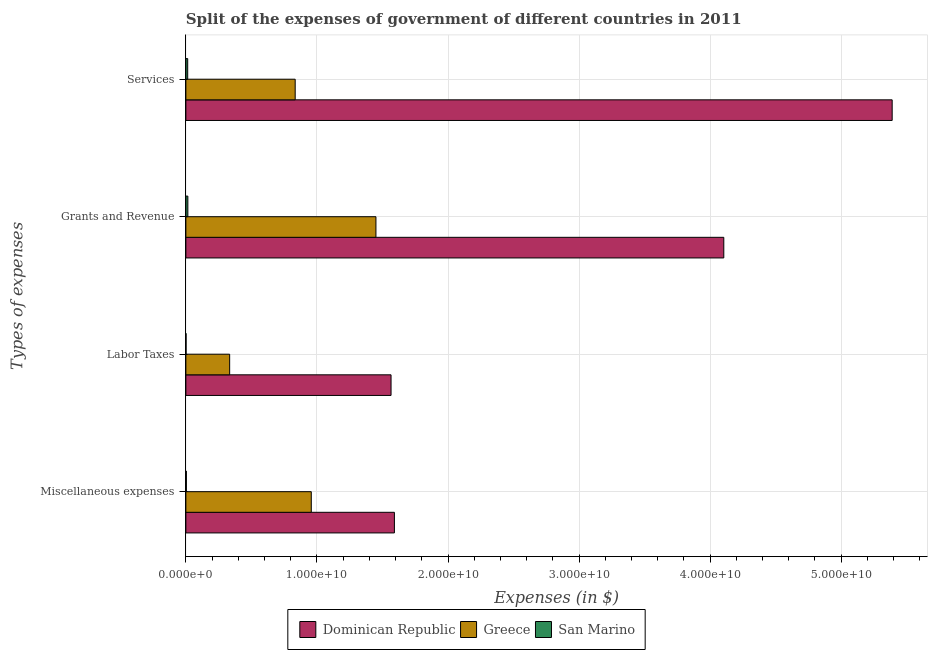How many groups of bars are there?
Your response must be concise. 4. How many bars are there on the 4th tick from the top?
Make the answer very short. 3. How many bars are there on the 3rd tick from the bottom?
Your answer should be very brief. 3. What is the label of the 3rd group of bars from the top?
Provide a succinct answer. Labor Taxes. What is the amount spent on miscellaneous expenses in Greece?
Offer a terse response. 9.57e+09. Across all countries, what is the maximum amount spent on services?
Your answer should be very brief. 5.39e+1. Across all countries, what is the minimum amount spent on miscellaneous expenses?
Provide a short and direct response. 3.76e+07. In which country was the amount spent on services maximum?
Keep it short and to the point. Dominican Republic. In which country was the amount spent on miscellaneous expenses minimum?
Ensure brevity in your answer.  San Marino. What is the total amount spent on miscellaneous expenses in the graph?
Provide a succinct answer. 2.55e+1. What is the difference between the amount spent on miscellaneous expenses in San Marino and that in Dominican Republic?
Make the answer very short. -1.59e+1. What is the difference between the amount spent on services in Dominican Republic and the amount spent on grants and revenue in Greece?
Make the answer very short. 3.94e+1. What is the average amount spent on miscellaneous expenses per country?
Offer a terse response. 8.51e+09. What is the difference between the amount spent on miscellaneous expenses and amount spent on services in Dominican Republic?
Keep it short and to the point. -3.80e+1. What is the ratio of the amount spent on labor taxes in San Marino to that in Greece?
Give a very brief answer. 0. Is the amount spent on services in Greece less than that in Dominican Republic?
Make the answer very short. Yes. Is the difference between the amount spent on services in Dominican Republic and Greece greater than the difference between the amount spent on labor taxes in Dominican Republic and Greece?
Make the answer very short. Yes. What is the difference between the highest and the second highest amount spent on grants and revenue?
Ensure brevity in your answer.  2.65e+1. What is the difference between the highest and the lowest amount spent on miscellaneous expenses?
Give a very brief answer. 1.59e+1. Is the sum of the amount spent on services in Dominican Republic and San Marino greater than the maximum amount spent on miscellaneous expenses across all countries?
Offer a very short reply. Yes. What does the 3rd bar from the top in Miscellaneous expenses represents?
Give a very brief answer. Dominican Republic. What does the 1st bar from the bottom in Services represents?
Make the answer very short. Dominican Republic. How many bars are there?
Your answer should be compact. 12. How many countries are there in the graph?
Give a very brief answer. 3. What is the difference between two consecutive major ticks on the X-axis?
Offer a terse response. 1.00e+1. Are the values on the major ticks of X-axis written in scientific E-notation?
Make the answer very short. Yes. Does the graph contain grids?
Provide a short and direct response. Yes. Where does the legend appear in the graph?
Ensure brevity in your answer.  Bottom center. How are the legend labels stacked?
Your answer should be compact. Horizontal. What is the title of the graph?
Offer a terse response. Split of the expenses of government of different countries in 2011. What is the label or title of the X-axis?
Ensure brevity in your answer.  Expenses (in $). What is the label or title of the Y-axis?
Your response must be concise. Types of expenses. What is the Expenses (in $) in Dominican Republic in Miscellaneous expenses?
Give a very brief answer. 1.59e+1. What is the Expenses (in $) of Greece in Miscellaneous expenses?
Your answer should be compact. 9.57e+09. What is the Expenses (in $) of San Marino in Miscellaneous expenses?
Your answer should be compact. 3.76e+07. What is the Expenses (in $) in Dominican Republic in Labor Taxes?
Offer a very short reply. 1.57e+1. What is the Expenses (in $) in Greece in Labor Taxes?
Your answer should be very brief. 3.34e+09. What is the Expenses (in $) of San Marino in Labor Taxes?
Your answer should be very brief. 1.45e+07. What is the Expenses (in $) in Dominican Republic in Grants and Revenue?
Your answer should be very brief. 4.10e+1. What is the Expenses (in $) of Greece in Grants and Revenue?
Offer a very short reply. 1.45e+1. What is the Expenses (in $) of San Marino in Grants and Revenue?
Offer a terse response. 1.51e+08. What is the Expenses (in $) in Dominican Republic in Services?
Offer a terse response. 5.39e+1. What is the Expenses (in $) in Greece in Services?
Provide a short and direct response. 8.34e+09. What is the Expenses (in $) in San Marino in Services?
Your response must be concise. 1.39e+08. Across all Types of expenses, what is the maximum Expenses (in $) in Dominican Republic?
Offer a terse response. 5.39e+1. Across all Types of expenses, what is the maximum Expenses (in $) in Greece?
Offer a very short reply. 1.45e+1. Across all Types of expenses, what is the maximum Expenses (in $) of San Marino?
Provide a succinct answer. 1.51e+08. Across all Types of expenses, what is the minimum Expenses (in $) of Dominican Republic?
Ensure brevity in your answer.  1.57e+1. Across all Types of expenses, what is the minimum Expenses (in $) in Greece?
Give a very brief answer. 3.34e+09. Across all Types of expenses, what is the minimum Expenses (in $) of San Marino?
Make the answer very short. 1.45e+07. What is the total Expenses (in $) in Dominican Republic in the graph?
Your answer should be very brief. 1.27e+11. What is the total Expenses (in $) in Greece in the graph?
Offer a terse response. 3.58e+1. What is the total Expenses (in $) of San Marino in the graph?
Your answer should be compact. 3.43e+08. What is the difference between the Expenses (in $) of Dominican Republic in Miscellaneous expenses and that in Labor Taxes?
Provide a succinct answer. 2.57e+08. What is the difference between the Expenses (in $) of Greece in Miscellaneous expenses and that in Labor Taxes?
Keep it short and to the point. 6.23e+09. What is the difference between the Expenses (in $) in San Marino in Miscellaneous expenses and that in Labor Taxes?
Your answer should be compact. 2.31e+07. What is the difference between the Expenses (in $) of Dominican Republic in Miscellaneous expenses and that in Grants and Revenue?
Your answer should be very brief. -2.51e+1. What is the difference between the Expenses (in $) of Greece in Miscellaneous expenses and that in Grants and Revenue?
Your answer should be very brief. -4.93e+09. What is the difference between the Expenses (in $) of San Marino in Miscellaneous expenses and that in Grants and Revenue?
Make the answer very short. -1.14e+08. What is the difference between the Expenses (in $) in Dominican Republic in Miscellaneous expenses and that in Services?
Your response must be concise. -3.80e+1. What is the difference between the Expenses (in $) of Greece in Miscellaneous expenses and that in Services?
Offer a terse response. 1.23e+09. What is the difference between the Expenses (in $) of San Marino in Miscellaneous expenses and that in Services?
Offer a terse response. -1.02e+08. What is the difference between the Expenses (in $) in Dominican Republic in Labor Taxes and that in Grants and Revenue?
Keep it short and to the point. -2.54e+1. What is the difference between the Expenses (in $) in Greece in Labor Taxes and that in Grants and Revenue?
Your answer should be very brief. -1.12e+1. What is the difference between the Expenses (in $) in San Marino in Labor Taxes and that in Grants and Revenue?
Your answer should be very brief. -1.37e+08. What is the difference between the Expenses (in $) of Dominican Republic in Labor Taxes and that in Services?
Keep it short and to the point. -3.82e+1. What is the difference between the Expenses (in $) in Greece in Labor Taxes and that in Services?
Your answer should be very brief. -5.00e+09. What is the difference between the Expenses (in $) of San Marino in Labor Taxes and that in Services?
Your answer should be very brief. -1.25e+08. What is the difference between the Expenses (in $) in Dominican Republic in Grants and Revenue and that in Services?
Your answer should be very brief. -1.28e+1. What is the difference between the Expenses (in $) of Greece in Grants and Revenue and that in Services?
Keep it short and to the point. 6.16e+09. What is the difference between the Expenses (in $) of San Marino in Grants and Revenue and that in Services?
Keep it short and to the point. 1.18e+07. What is the difference between the Expenses (in $) in Dominican Republic in Miscellaneous expenses and the Expenses (in $) in Greece in Labor Taxes?
Ensure brevity in your answer.  1.26e+1. What is the difference between the Expenses (in $) of Dominican Republic in Miscellaneous expenses and the Expenses (in $) of San Marino in Labor Taxes?
Ensure brevity in your answer.  1.59e+1. What is the difference between the Expenses (in $) in Greece in Miscellaneous expenses and the Expenses (in $) in San Marino in Labor Taxes?
Provide a short and direct response. 9.55e+09. What is the difference between the Expenses (in $) of Dominican Republic in Miscellaneous expenses and the Expenses (in $) of Greece in Grants and Revenue?
Give a very brief answer. 1.41e+09. What is the difference between the Expenses (in $) in Dominican Republic in Miscellaneous expenses and the Expenses (in $) in San Marino in Grants and Revenue?
Provide a succinct answer. 1.58e+1. What is the difference between the Expenses (in $) of Greece in Miscellaneous expenses and the Expenses (in $) of San Marino in Grants and Revenue?
Your answer should be compact. 9.42e+09. What is the difference between the Expenses (in $) of Dominican Republic in Miscellaneous expenses and the Expenses (in $) of Greece in Services?
Ensure brevity in your answer.  7.57e+09. What is the difference between the Expenses (in $) of Dominican Republic in Miscellaneous expenses and the Expenses (in $) of San Marino in Services?
Your answer should be very brief. 1.58e+1. What is the difference between the Expenses (in $) of Greece in Miscellaneous expenses and the Expenses (in $) of San Marino in Services?
Offer a very short reply. 9.43e+09. What is the difference between the Expenses (in $) in Dominican Republic in Labor Taxes and the Expenses (in $) in Greece in Grants and Revenue?
Offer a very short reply. 1.15e+09. What is the difference between the Expenses (in $) in Dominican Republic in Labor Taxes and the Expenses (in $) in San Marino in Grants and Revenue?
Make the answer very short. 1.55e+1. What is the difference between the Expenses (in $) in Greece in Labor Taxes and the Expenses (in $) in San Marino in Grants and Revenue?
Offer a terse response. 3.19e+09. What is the difference between the Expenses (in $) in Dominican Republic in Labor Taxes and the Expenses (in $) in Greece in Services?
Ensure brevity in your answer.  7.31e+09. What is the difference between the Expenses (in $) of Dominican Republic in Labor Taxes and the Expenses (in $) of San Marino in Services?
Your response must be concise. 1.55e+1. What is the difference between the Expenses (in $) in Greece in Labor Taxes and the Expenses (in $) in San Marino in Services?
Offer a very short reply. 3.20e+09. What is the difference between the Expenses (in $) of Dominican Republic in Grants and Revenue and the Expenses (in $) of Greece in Services?
Provide a succinct answer. 3.27e+1. What is the difference between the Expenses (in $) of Dominican Republic in Grants and Revenue and the Expenses (in $) of San Marino in Services?
Your answer should be very brief. 4.09e+1. What is the difference between the Expenses (in $) in Greece in Grants and Revenue and the Expenses (in $) in San Marino in Services?
Keep it short and to the point. 1.44e+1. What is the average Expenses (in $) of Dominican Republic per Types of expenses?
Offer a terse response. 3.16e+1. What is the average Expenses (in $) of Greece per Types of expenses?
Provide a short and direct response. 8.94e+09. What is the average Expenses (in $) in San Marino per Types of expenses?
Ensure brevity in your answer.  8.57e+07. What is the difference between the Expenses (in $) in Dominican Republic and Expenses (in $) in Greece in Miscellaneous expenses?
Your response must be concise. 6.34e+09. What is the difference between the Expenses (in $) in Dominican Republic and Expenses (in $) in San Marino in Miscellaneous expenses?
Keep it short and to the point. 1.59e+1. What is the difference between the Expenses (in $) in Greece and Expenses (in $) in San Marino in Miscellaneous expenses?
Offer a very short reply. 9.53e+09. What is the difference between the Expenses (in $) of Dominican Republic and Expenses (in $) of Greece in Labor Taxes?
Provide a short and direct response. 1.23e+1. What is the difference between the Expenses (in $) of Dominican Republic and Expenses (in $) of San Marino in Labor Taxes?
Give a very brief answer. 1.56e+1. What is the difference between the Expenses (in $) in Greece and Expenses (in $) in San Marino in Labor Taxes?
Keep it short and to the point. 3.33e+09. What is the difference between the Expenses (in $) in Dominican Republic and Expenses (in $) in Greece in Grants and Revenue?
Ensure brevity in your answer.  2.65e+1. What is the difference between the Expenses (in $) of Dominican Republic and Expenses (in $) of San Marino in Grants and Revenue?
Provide a succinct answer. 4.09e+1. What is the difference between the Expenses (in $) of Greece and Expenses (in $) of San Marino in Grants and Revenue?
Provide a short and direct response. 1.44e+1. What is the difference between the Expenses (in $) in Dominican Republic and Expenses (in $) in Greece in Services?
Your answer should be compact. 4.56e+1. What is the difference between the Expenses (in $) of Dominican Republic and Expenses (in $) of San Marino in Services?
Your answer should be compact. 5.38e+1. What is the difference between the Expenses (in $) of Greece and Expenses (in $) of San Marino in Services?
Keep it short and to the point. 8.20e+09. What is the ratio of the Expenses (in $) of Dominican Republic in Miscellaneous expenses to that in Labor Taxes?
Keep it short and to the point. 1.02. What is the ratio of the Expenses (in $) in Greece in Miscellaneous expenses to that in Labor Taxes?
Offer a very short reply. 2.86. What is the ratio of the Expenses (in $) in San Marino in Miscellaneous expenses to that in Labor Taxes?
Make the answer very short. 2.59. What is the ratio of the Expenses (in $) in Dominican Republic in Miscellaneous expenses to that in Grants and Revenue?
Provide a short and direct response. 0.39. What is the ratio of the Expenses (in $) of Greece in Miscellaneous expenses to that in Grants and Revenue?
Your answer should be compact. 0.66. What is the ratio of the Expenses (in $) in San Marino in Miscellaneous expenses to that in Grants and Revenue?
Offer a very short reply. 0.25. What is the ratio of the Expenses (in $) of Dominican Republic in Miscellaneous expenses to that in Services?
Offer a terse response. 0.3. What is the ratio of the Expenses (in $) of Greece in Miscellaneous expenses to that in Services?
Your answer should be compact. 1.15. What is the ratio of the Expenses (in $) in San Marino in Miscellaneous expenses to that in Services?
Offer a very short reply. 0.27. What is the ratio of the Expenses (in $) of Dominican Republic in Labor Taxes to that in Grants and Revenue?
Keep it short and to the point. 0.38. What is the ratio of the Expenses (in $) of Greece in Labor Taxes to that in Grants and Revenue?
Provide a short and direct response. 0.23. What is the ratio of the Expenses (in $) in San Marino in Labor Taxes to that in Grants and Revenue?
Your answer should be compact. 0.1. What is the ratio of the Expenses (in $) of Dominican Republic in Labor Taxes to that in Services?
Your response must be concise. 0.29. What is the ratio of the Expenses (in $) in Greece in Labor Taxes to that in Services?
Offer a very short reply. 0.4. What is the ratio of the Expenses (in $) of San Marino in Labor Taxes to that in Services?
Your answer should be very brief. 0.1. What is the ratio of the Expenses (in $) in Dominican Republic in Grants and Revenue to that in Services?
Provide a short and direct response. 0.76. What is the ratio of the Expenses (in $) of Greece in Grants and Revenue to that in Services?
Offer a terse response. 1.74. What is the ratio of the Expenses (in $) in San Marino in Grants and Revenue to that in Services?
Keep it short and to the point. 1.08. What is the difference between the highest and the second highest Expenses (in $) of Dominican Republic?
Give a very brief answer. 1.28e+1. What is the difference between the highest and the second highest Expenses (in $) of Greece?
Offer a terse response. 4.93e+09. What is the difference between the highest and the second highest Expenses (in $) of San Marino?
Make the answer very short. 1.18e+07. What is the difference between the highest and the lowest Expenses (in $) in Dominican Republic?
Your answer should be compact. 3.82e+1. What is the difference between the highest and the lowest Expenses (in $) in Greece?
Offer a very short reply. 1.12e+1. What is the difference between the highest and the lowest Expenses (in $) of San Marino?
Your answer should be very brief. 1.37e+08. 